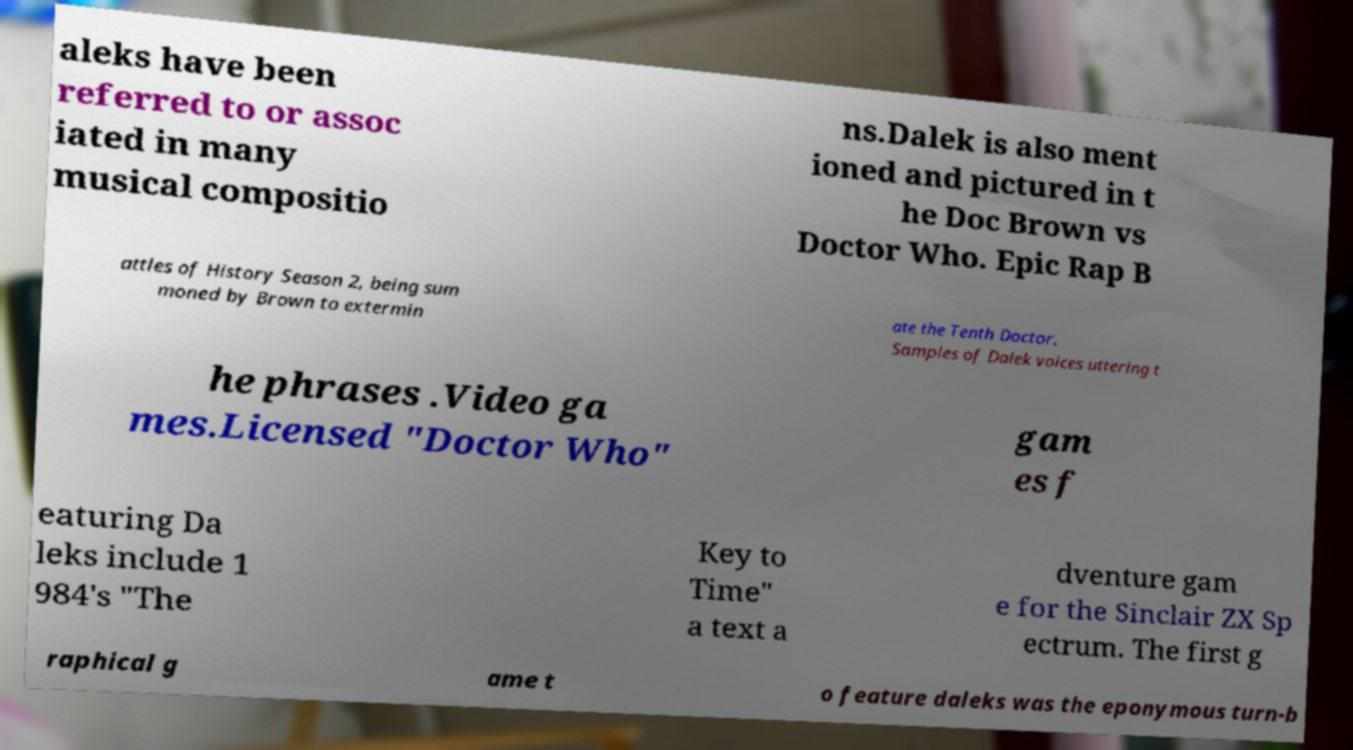Please read and relay the text visible in this image. What does it say? aleks have been referred to or assoc iated in many musical compositio ns.Dalek is also ment ioned and pictured in t he Doc Brown vs Doctor Who. Epic Rap B attles of History Season 2, being sum moned by Brown to extermin ate the Tenth Doctor. Samples of Dalek voices uttering t he phrases .Video ga mes.Licensed "Doctor Who" gam es f eaturing Da leks include 1 984's "The Key to Time" a text a dventure gam e for the Sinclair ZX Sp ectrum. The first g raphical g ame t o feature daleks was the eponymous turn-b 